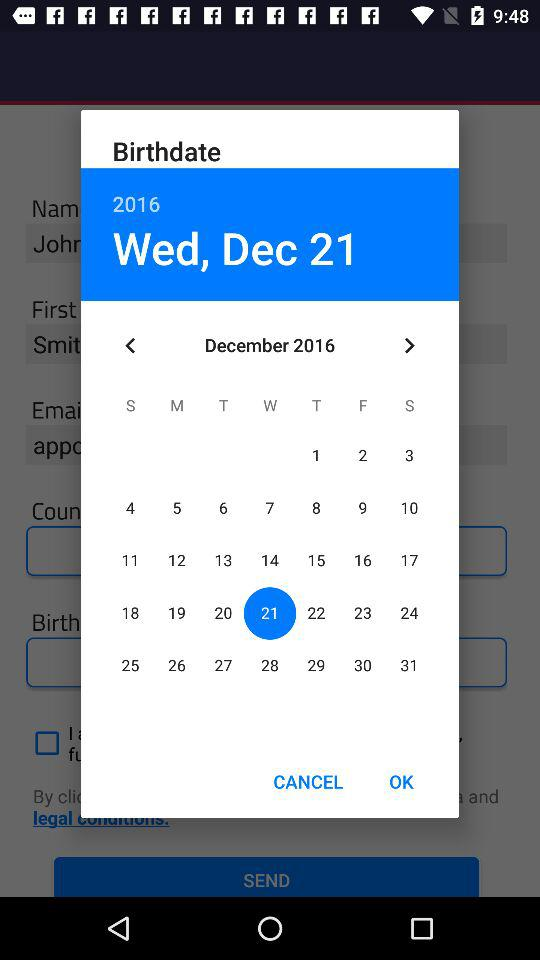Which month is displayed on the calendar? The month displayed on the calendar is December. 